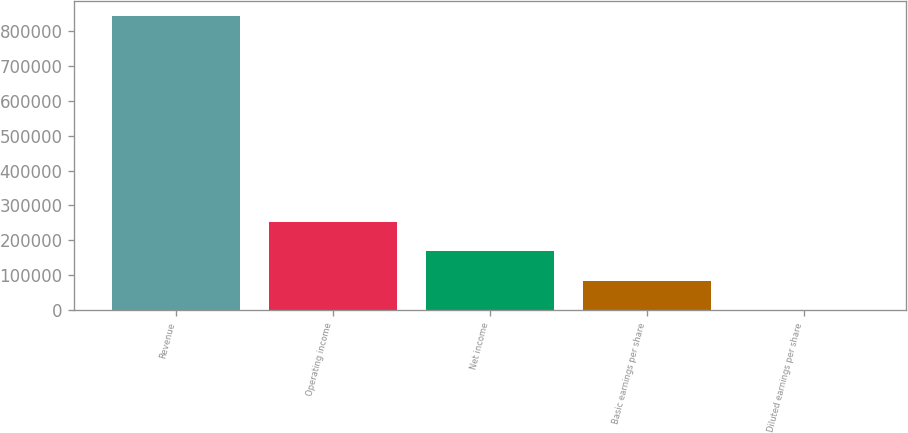<chart> <loc_0><loc_0><loc_500><loc_500><bar_chart><fcel>Revenue<fcel>Operating income<fcel>Net income<fcel>Basic earnings per share<fcel>Diluted earnings per share<nl><fcel>844147<fcel>253246<fcel>168831<fcel>84417<fcel>2.53<nl></chart> 